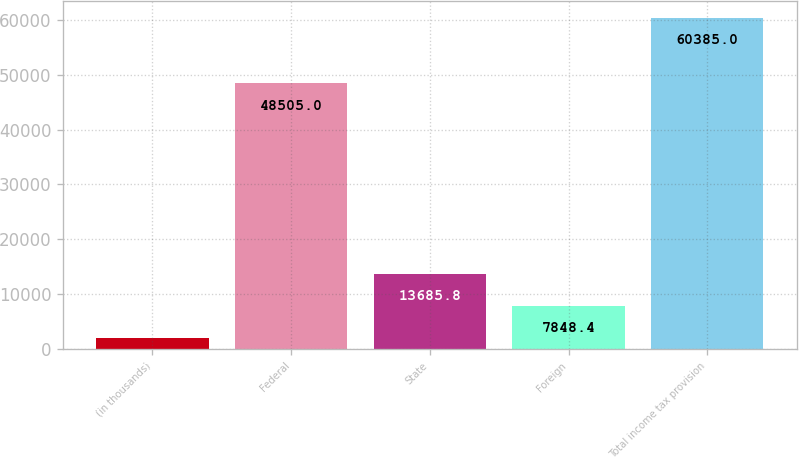<chart> <loc_0><loc_0><loc_500><loc_500><bar_chart><fcel>(in thousands)<fcel>Federal<fcel>State<fcel>Foreign<fcel>Total income tax provision<nl><fcel>2011<fcel>48505<fcel>13685.8<fcel>7848.4<fcel>60385<nl></chart> 